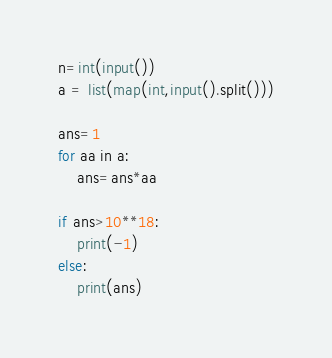<code> <loc_0><loc_0><loc_500><loc_500><_Python_>n=int(input())
a = list(map(int,input().split()))

ans=1
for aa in a:
    ans=ans*aa

if ans>10**18:
    print(-1)
else:
    print(ans)</code> 